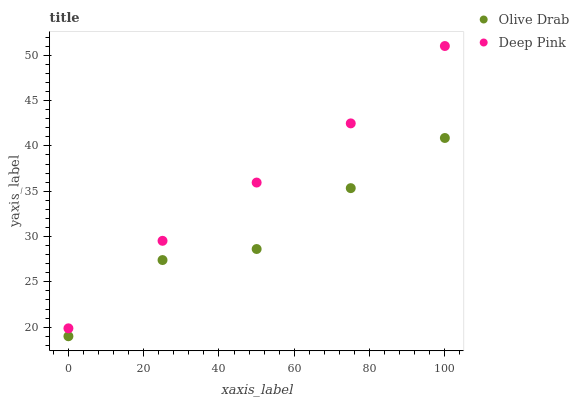Does Olive Drab have the minimum area under the curve?
Answer yes or no. Yes. Does Deep Pink have the maximum area under the curve?
Answer yes or no. Yes. Does Olive Drab have the maximum area under the curve?
Answer yes or no. No. Is Deep Pink the smoothest?
Answer yes or no. Yes. Is Olive Drab the roughest?
Answer yes or no. Yes. Is Olive Drab the smoothest?
Answer yes or no. No. Does Olive Drab have the lowest value?
Answer yes or no. Yes. Does Deep Pink have the highest value?
Answer yes or no. Yes. Does Olive Drab have the highest value?
Answer yes or no. No. Is Olive Drab less than Deep Pink?
Answer yes or no. Yes. Is Deep Pink greater than Olive Drab?
Answer yes or no. Yes. Does Olive Drab intersect Deep Pink?
Answer yes or no. No. 